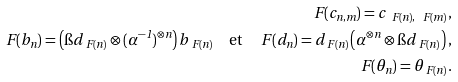Convert formula to latex. <formula><loc_0><loc_0><loc_500><loc_500>\ F ( c _ { n , m } ) = c _ { \ F ( n ) , \ F ( m ) } , \\ \ F ( b _ { n } ) = \left ( \i d _ { \ F ( n ) } \otimes ( \alpha ^ { - 1 } ) ^ { \otimes n } \right ) b _ { \ F ( n ) } \quad \text {et} \quad \ F ( d _ { n } ) = d _ { \ F ( n ) } \left ( \alpha ^ { \otimes n } \otimes \i d _ { \ F ( n ) } \right ) , \\ \ F ( \theta _ { n } ) = \theta _ { \ F ( n ) } .</formula> 